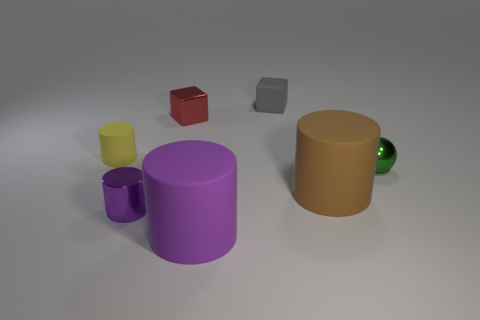What size is the thing that is the same color as the tiny metallic cylinder?
Give a very brief answer. Large. What number of things are rubber cylinders right of the tiny yellow object or metal blocks?
Provide a short and direct response. 3. What number of large brown cylinders are made of the same material as the small gray thing?
Your response must be concise. 1. There is a object that is the same color as the tiny shiny cylinder; what shape is it?
Keep it short and to the point. Cylinder. Are there the same number of purple things behind the red metal object and small red objects?
Ensure brevity in your answer.  No. What size is the metallic thing that is right of the brown thing?
Give a very brief answer. Small. How many large things are yellow rubber cylinders or cyan metal cylinders?
Make the answer very short. 0. There is another big object that is the same shape as the big purple rubber object; what color is it?
Your response must be concise. Brown. Do the yellow object and the purple metal thing have the same size?
Your answer should be compact. Yes. How many objects are rubber objects or large matte objects that are right of the large purple object?
Offer a terse response. 4. 